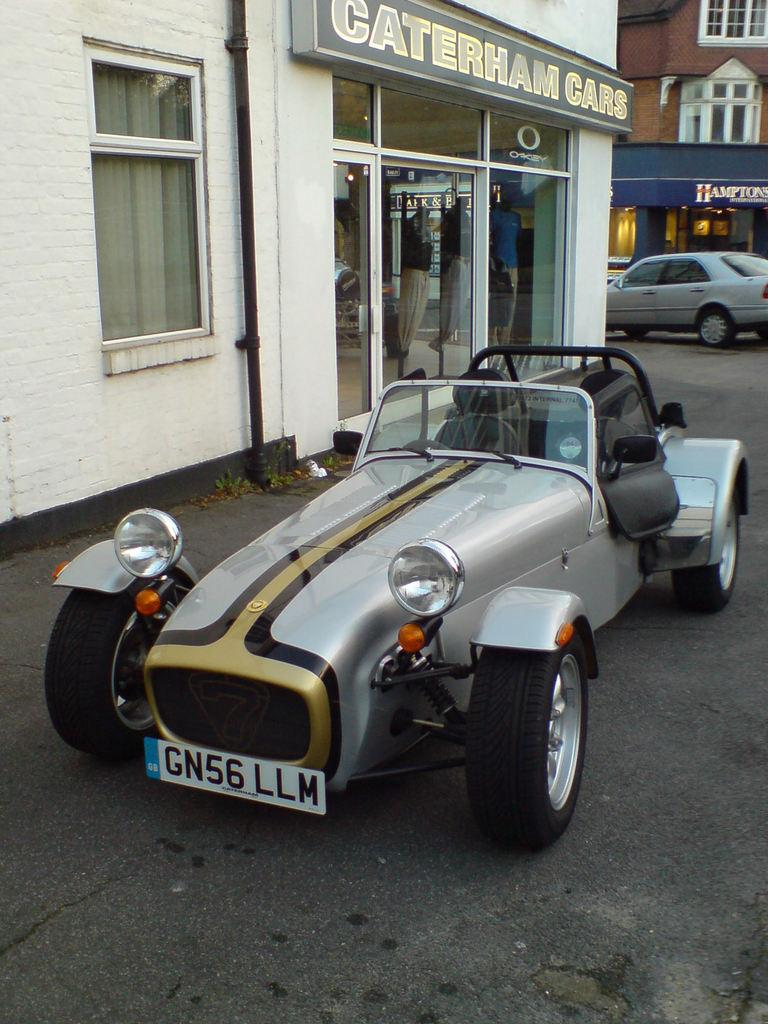What can be seen on the road in the image? There are vehicles on the road in the image. What type of structures are visible in the image? There are buildings with windows in the image. What are the name boards used for in the image? The name boards are used for identification or direction in the image. What is the pipe used for in the image? The pipe's purpose cannot be determined from the image alone, but it is likely used for transporting fluids or gases. What type of window treatment is present in the image? There is a curtain in the image. What type of ray can be seen swimming in the image? There is no ray present in the image; it features vehicles on the road, buildings with windows, name boards, a pipe, and a curtain. What type of pickle is being served with the stew in the image? There is no stew or pickle present in the image; it focuses on vehicles, buildings, name boards, a pipe, and a curtain. 